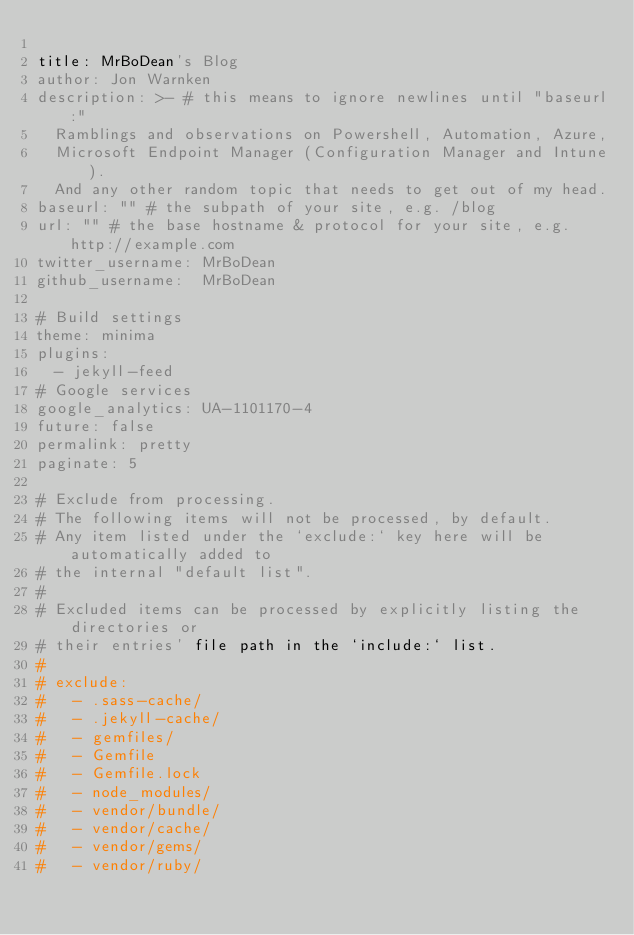<code> <loc_0><loc_0><loc_500><loc_500><_YAML_>
title: MrBoDean's Blog
author: Jon Warnken
description: >- # this means to ignore newlines until "baseurl:"
  Ramblings and observations on Powershell, Automation, Azure, 
  Microsoft Endpoint Manager (Configuration Manager and Intune). 
  And any other random topic that needs to get out of my head. 
baseurl: "" # the subpath of your site, e.g. /blog
url: "" # the base hostname & protocol for your site, e.g. http://example.com
twitter_username: MrBoDean
github_username:  MrBoDean

# Build settings
theme: minima
plugins:
  - jekyll-feed
# Google services
google_analytics: UA-1101170-4
future: false
permalink: pretty
paginate: 5

# Exclude from processing.
# The following items will not be processed, by default.
# Any item listed under the `exclude:` key here will be automatically added to
# the internal "default list".
#
# Excluded items can be processed by explicitly listing the directories or
# their entries' file path in the `include:` list.
#
# exclude:
#   - .sass-cache/
#   - .jekyll-cache/
#   - gemfiles/
#   - Gemfile
#   - Gemfile.lock
#   - node_modules/
#   - vendor/bundle/
#   - vendor/cache/
#   - vendor/gems/
#   - vendor/ruby/
</code> 